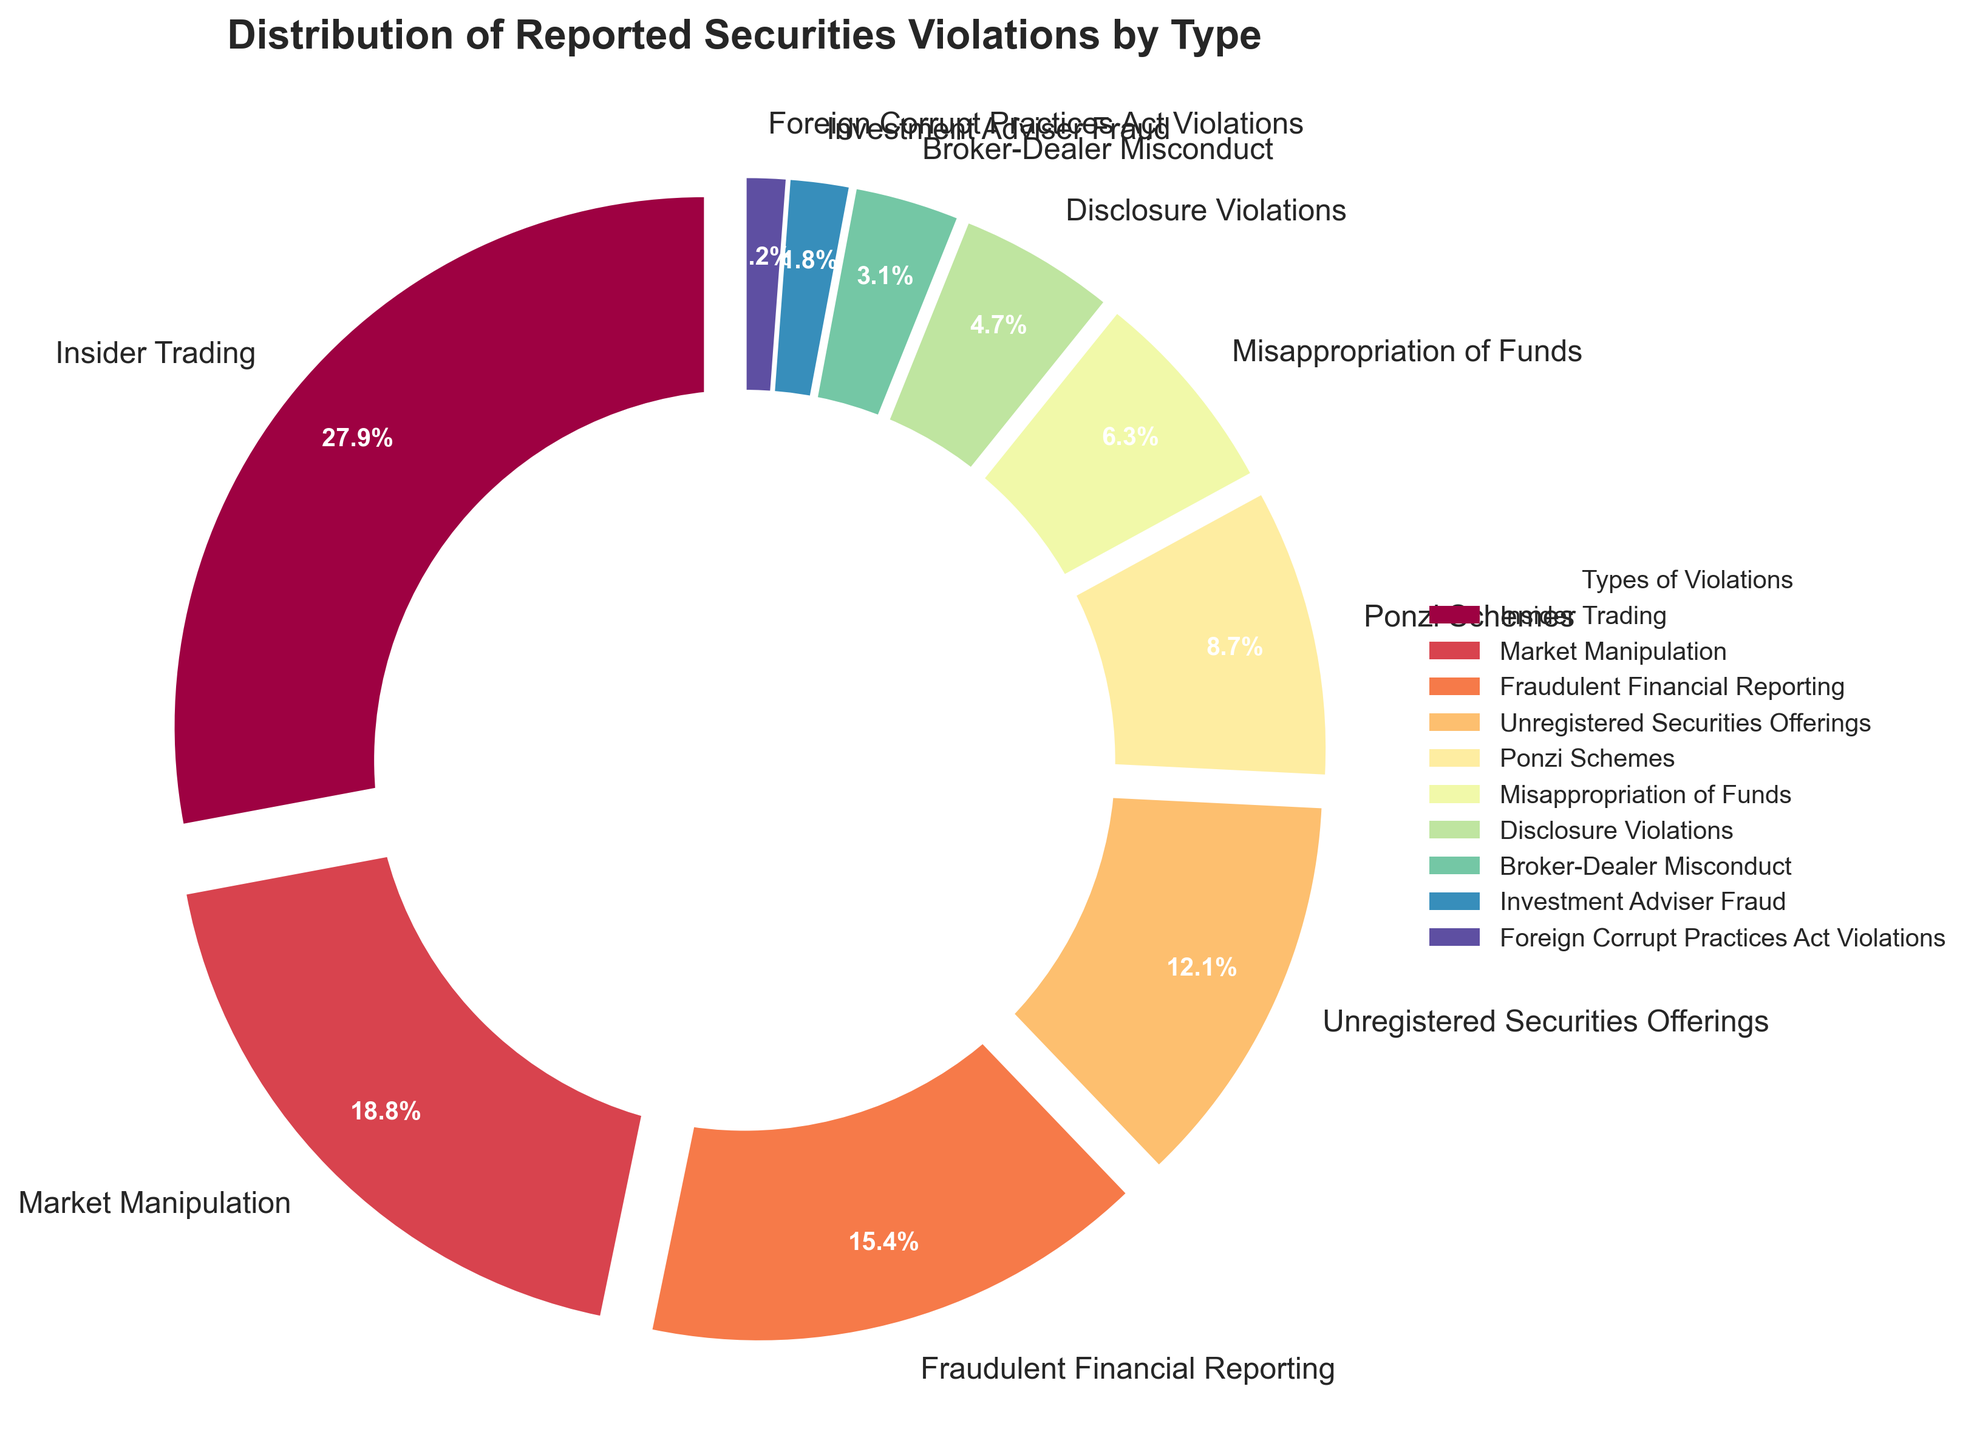What type of securities violation has the highest percentage? Identify the segment with the largest percentage displayed and its corresponding label.
Answer: Insider Trading Which type of securities violation is reported less frequently: Broker-Dealer Misconduct or Investment Adviser Fraud? Compare the percentages for Broker-Dealer Misconduct (3.2%) and Investment Adviser Fraud (1.8%) and determine which is smaller.
Answer: Investment Adviser Fraud What is the combined percentage of Insider Trading and Market Manipulation violations? Add the percentages for Insider Trading (28.5%) and Market Manipulation (19.2%): 28.5 + 19.2 = 47.7%.
Answer: 47.7% How much more frequent is Fraudulent Financial Reporting compared to Disclosure Violations? Subtract the percentage of Disclosure Violations (4.8%) from Fraudulent Financial Reporting (15.7%): 15.7 - 4.8 = 10.9%.
Answer: 10.9% Which type of violation accounts for less than 5% of the total reported violations? Find all violation types with percentages less than 5%. Disclosure Violations (4.8%), Broker-Dealer Misconduct (3.2%), Investment Adviser Fraud (1.8%), and Foreign Corrupt Practices Act Violations (1.2%) all qualify.
Answer: Disclosure Violations, Broker-Dealer Misconduct, Investment Adviser Fraud, Foreign Corrupt Practices Act Violations Is the percentage of Unregistered Securities Offerings violations greater than Ponzi Schemes violations? Compare the percentages for Unregistered Securities Offerings (12.3%) and Ponzi Schemes (8.9%) and determine which is greater.
Answer: Yes If the percentages of Insider Trading and Market Manipulation violations are combined, does it exceed 50% of total violations reported? Add the percentages for Insider Trading (28.5%) and Market Manipulation (19.2%), which results in 47.7%. Determine if this value is greater than 50%.
Answer: No What is the visual indicator used to distinguish different types of violations in the pie chart? Identify the visual attributes of the chart elements (colors, labels). Each segment is distinguished by unique colors and labels.
Answer: Different colors and labels 